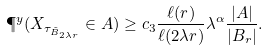Convert formula to latex. <formula><loc_0><loc_0><loc_500><loc_500>\P ^ { y } ( X _ { \tau _ { \tilde { B } _ { 2 \lambda r } } } \in A ) \geq c _ { 3 } \frac { \ell ( r ) } { \ell ( 2 \lambda r ) } \lambda ^ { \alpha } \frac { | A | } { | B _ { r } | } .</formula> 